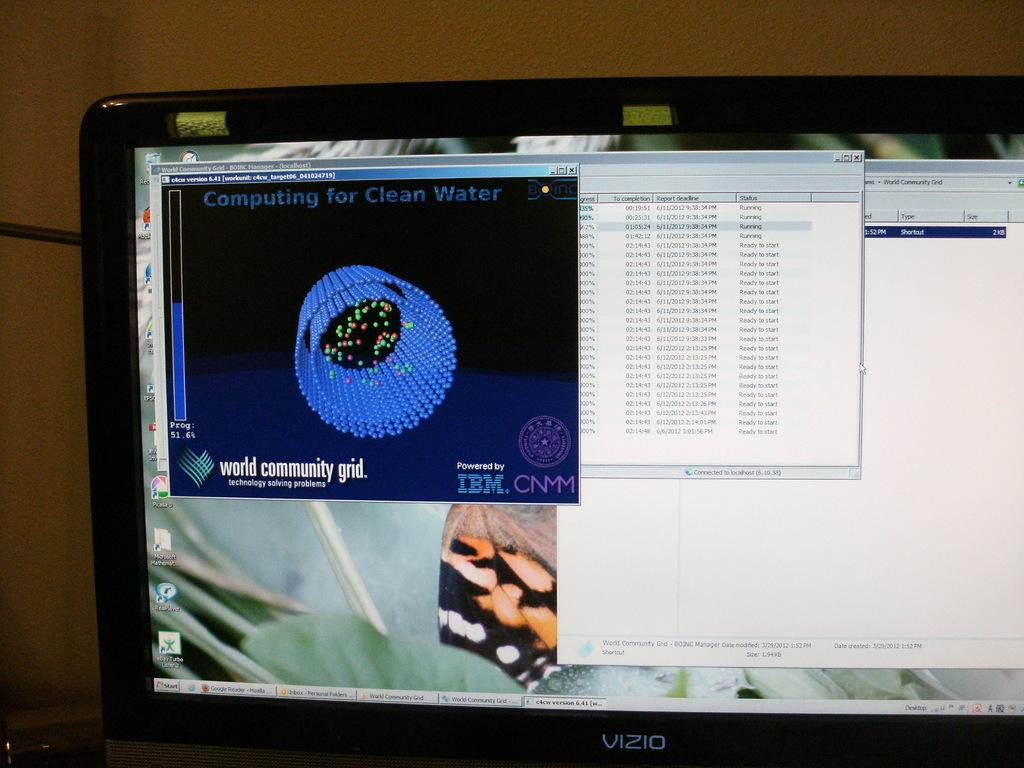What is the main object in the image? There is a laptop screen in the image. What else can be seen in the background of the image? There is a cable and a wall in the background of the image. How many children are playing in the field behind the wall in the image? There are no children or fields present in the image; it only features a laptop screen, a cable, and a wall in the background. 